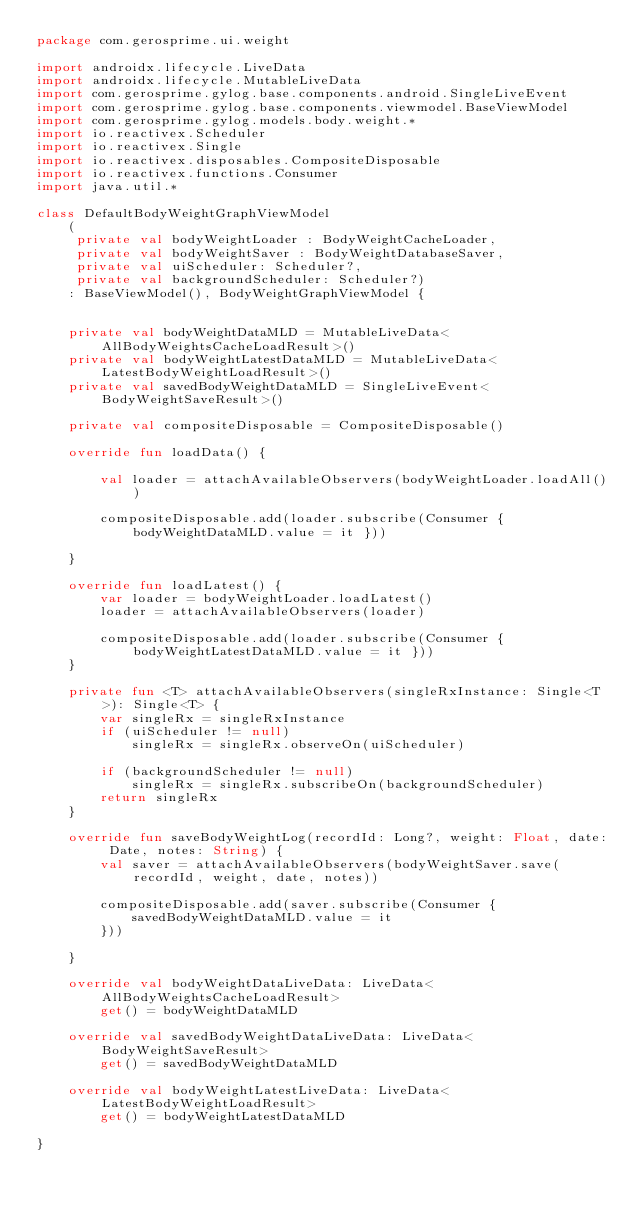Convert code to text. <code><loc_0><loc_0><loc_500><loc_500><_Kotlin_>package com.gerosprime.ui.weight

import androidx.lifecycle.LiveData
import androidx.lifecycle.MutableLiveData
import com.gerosprime.gylog.base.components.android.SingleLiveEvent
import com.gerosprime.gylog.base.components.viewmodel.BaseViewModel
import com.gerosprime.gylog.models.body.weight.*
import io.reactivex.Scheduler
import io.reactivex.Single
import io.reactivex.disposables.CompositeDisposable
import io.reactivex.functions.Consumer
import java.util.*

class DefaultBodyWeightGraphViewModel
    (
     private val bodyWeightLoader : BodyWeightCacheLoader,
     private val bodyWeightSaver : BodyWeightDatabaseSaver,
     private val uiScheduler: Scheduler?,
     private val backgroundScheduler: Scheduler?)
    : BaseViewModel(), BodyWeightGraphViewModel {


    private val bodyWeightDataMLD = MutableLiveData<AllBodyWeightsCacheLoadResult>()
    private val bodyWeightLatestDataMLD = MutableLiveData<LatestBodyWeightLoadResult>()
    private val savedBodyWeightDataMLD = SingleLiveEvent<BodyWeightSaveResult>()

    private val compositeDisposable = CompositeDisposable()

    override fun loadData() {

        val loader = attachAvailableObservers(bodyWeightLoader.loadAll())

        compositeDisposable.add(loader.subscribe(Consumer { bodyWeightDataMLD.value = it }))

    }

    override fun loadLatest() {
        var loader = bodyWeightLoader.loadLatest()
        loader = attachAvailableObservers(loader)

        compositeDisposable.add(loader.subscribe(Consumer { bodyWeightLatestDataMLD.value = it }))
    }

    private fun <T> attachAvailableObservers(singleRxInstance: Single<T>): Single<T> {
        var singleRx = singleRxInstance
        if (uiScheduler != null)
            singleRx = singleRx.observeOn(uiScheduler)

        if (backgroundScheduler != null)
            singleRx = singleRx.subscribeOn(backgroundScheduler)
        return singleRx
    }

    override fun saveBodyWeightLog(recordId: Long?, weight: Float, date: Date, notes: String) {
        val saver = attachAvailableObservers(bodyWeightSaver.save(recordId, weight, date, notes))

        compositeDisposable.add(saver.subscribe(Consumer {
            savedBodyWeightDataMLD.value = it
        }))

    }

    override val bodyWeightDataLiveData: LiveData<AllBodyWeightsCacheLoadResult>
        get() = bodyWeightDataMLD

    override val savedBodyWeightDataLiveData: LiveData<BodyWeightSaveResult>
        get() = savedBodyWeightDataMLD

    override val bodyWeightLatestLiveData: LiveData<LatestBodyWeightLoadResult>
        get() = bodyWeightLatestDataMLD

}</code> 